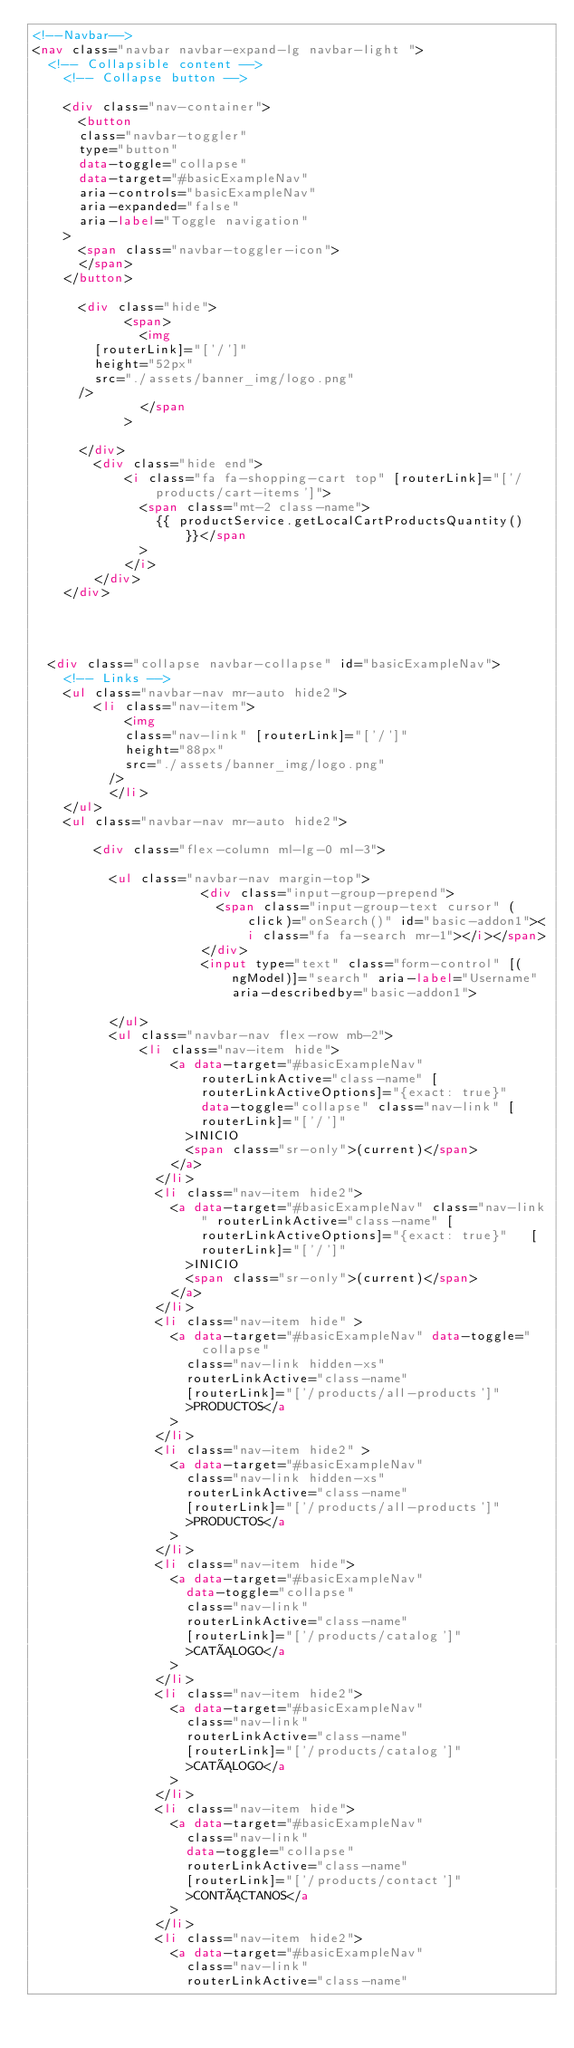Convert code to text. <code><loc_0><loc_0><loc_500><loc_500><_HTML_><!--Navbar-->
<nav class="navbar navbar-expand-lg navbar-light ">
  <!-- Collapsible content -->
    <!-- Collapse button -->
    
    <div class="nav-container">
      <button
      class="navbar-toggler"
      type="button"
      data-toggle="collapse"
      data-target="#basicExampleNav"
      aria-controls="basicExampleNav"
      aria-expanded="false"
      aria-label="Toggle navigation"
    >
      <span class="navbar-toggler-icon">
      </span>
    </button>
  
      <div class="hide">
            <span>
              <img
        [routerLink]="['/']"
        height="52px"
        src="./assets/banner_img/logo.png"
      />
              </span
            >
       
      </div>
        <div class="hide end">
            <i class="fa fa-shopping-cart top" [routerLink]="['/products/cart-items']">
              <span class="mt-2 class-name">
                {{ productService.getLocalCartProductsQuantity() }}</span
              >
            </i>
        </div>
    </div>


  

  <div class="collapse navbar-collapse" id="basicExampleNav">
    <!-- Links -->
    <ul class="navbar-nav mr-auto hide2">
        <li class="nav-item">
            <img
            class="nav-link" [routerLink]="['/']"
            height="88px"
            src="./assets/banner_img/logo.png"
          />
          </li>
    </ul>
    <ul class="navbar-nav mr-auto hide2">

        <div class="flex-column ml-lg-0 ml-3">

          <ul class="navbar-nav margin-top">
                      <div class="input-group-prepend">
                        <span class="input-group-text cursor" (click)="onSearch()" id="basic-addon1"><i class="fa fa-search mr-1"></i></span>
                      </div>
                      <input type="text" class="form-control" [(ngModel)]="search" aria-label="Username" aria-describedby="basic-addon1">
           
          </ul>
          <ul class="navbar-nav flex-row mb-2">
              <li class="nav-item hide">
                  <a data-target="#basicExampleNav" routerLinkActive="class-name" [routerLinkActiveOptions]="{exact: true}"   data-toggle="collapse" class="nav-link" [routerLink]="['/']"
                    >INICIO
                    <span class="sr-only">(current)</span>
                  </a>
                </li>
                <li class="nav-item hide2">
                  <a data-target="#basicExampleNav" class="nav-link" routerLinkActive="class-name" [routerLinkActiveOptions]="{exact: true}"   [routerLink]="['/']"
                    >INICIO
                    <span class="sr-only">(current)</span>
                  </a>
                </li>
                <li class="nav-item hide" >
                  <a data-target="#basicExampleNav" data-toggle="collapse"
                    class="nav-link hidden-xs"
                    routerLinkActive="class-name" 
                    [routerLink]="['/products/all-products']"
                    >PRODUCTOS</a
                  >
                </li>
                <li class="nav-item hide2" >
                  <a data-target="#basicExampleNav"
                    class="nav-link hidden-xs"
                    routerLinkActive="class-name" 
                    [routerLink]="['/products/all-products']"
                    >PRODUCTOS</a
                  >
                </li>
                <li class="nav-item hide">
                  <a data-target="#basicExampleNav"
                    data-toggle="collapse"
                    class="nav-link"
                    routerLinkActive="class-name" 
                    [routerLink]="['/products/catalog']"
                    >CATÁLOGO</a
                  >
                </li>
                <li class="nav-item hide2">
                  <a data-target="#basicExampleNav"
                    class="nav-link"
                    routerLinkActive="class-name" 
                    [routerLink]="['/products/catalog']"
                    >CATÁLOGO</a
                  >
                </li>
                <li class="nav-item hide">
                  <a data-target="#basicExampleNav"
                    class="nav-link"
                    data-toggle="collapse"
                    routerLinkActive="class-name" 
                    [routerLink]="['/products/contact']"
                    >CONTÁCTANOS</a
                  >
                </li>
                <li class="nav-item hide2">
                  <a data-target="#basicExampleNav"
                    class="nav-link"
                    routerLinkActive="class-name" </code> 